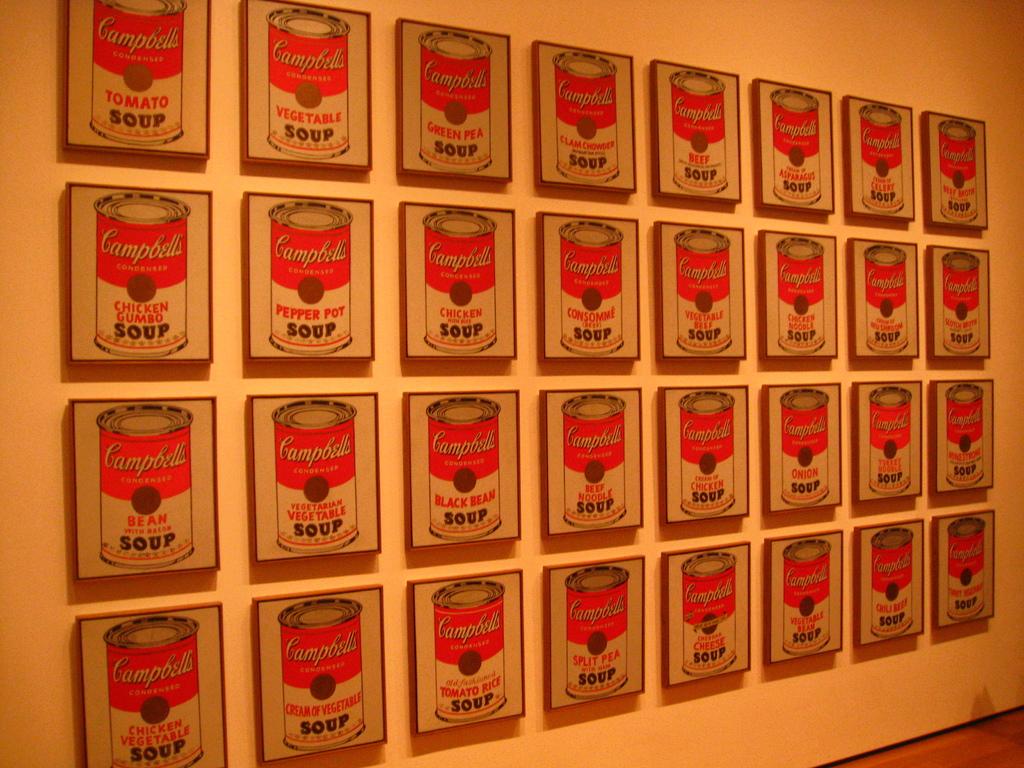What brand is in each painting?
Your response must be concise. Campbell's. What brand of soup?
Keep it short and to the point. Campbell's. 